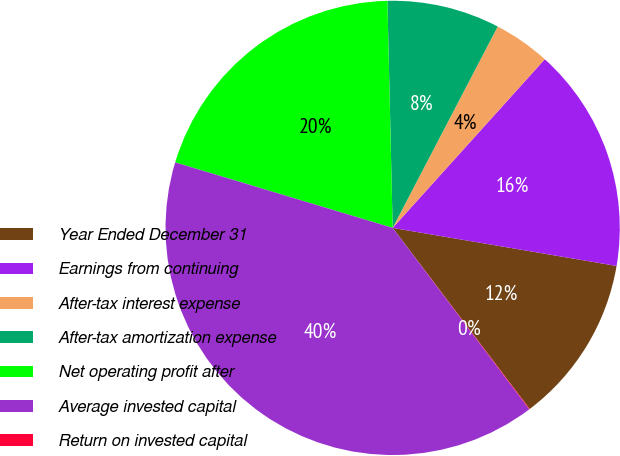<chart> <loc_0><loc_0><loc_500><loc_500><pie_chart><fcel>Year Ended December 31<fcel>Earnings from continuing<fcel>After-tax interest expense<fcel>After-tax amortization expense<fcel>Net operating profit after<fcel>Average invested capital<fcel>Return on invested capital<nl><fcel>12.01%<fcel>16.0%<fcel>4.03%<fcel>8.02%<fcel>19.98%<fcel>39.93%<fcel>0.04%<nl></chart> 